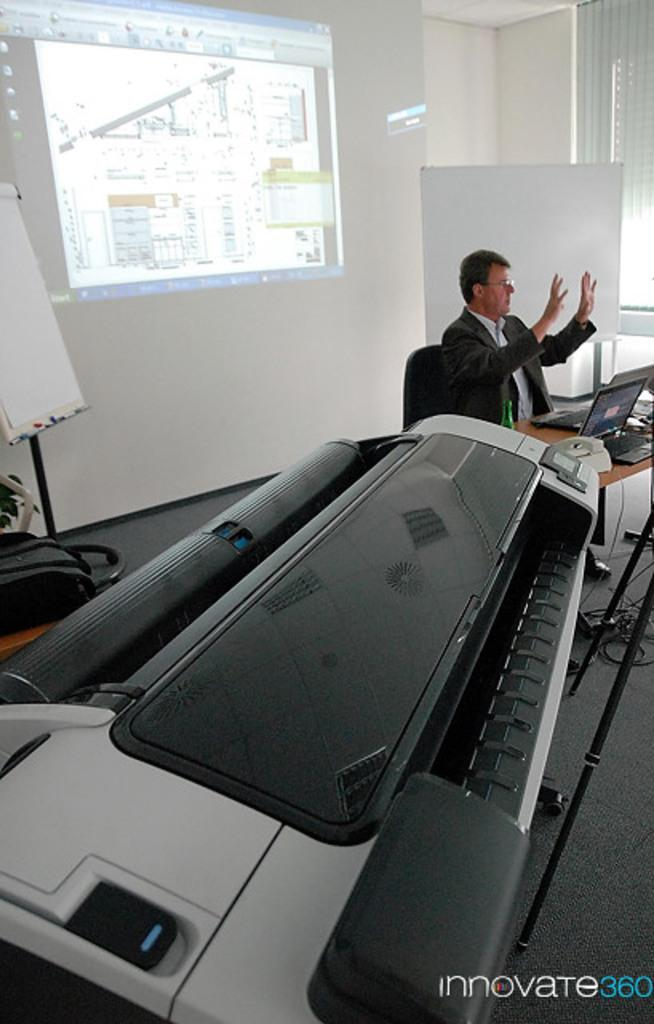What is the man in the image doing? The man is seated and speaking in the image. What is the purpose of the projector screen in the image? The projector screen is likely used for displaying visuals during the man's speech. What can be seen on the table in the image? There is a laptop on the table in the image. What other object is present in the image? There is a machine in the image. What type of twig can be seen growing out of the man's back in the image? There is no twig or any plant growth visible on the man's back in the image. 